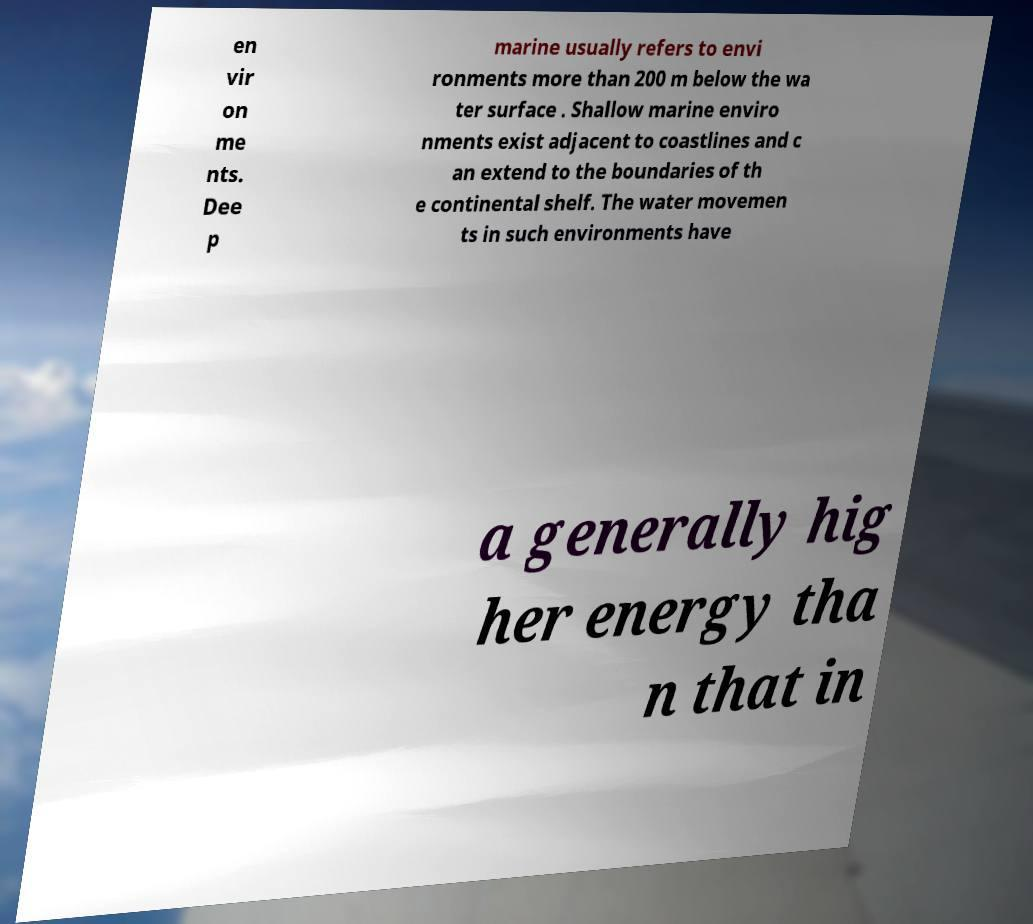Please identify and transcribe the text found in this image. en vir on me nts. Dee p marine usually refers to envi ronments more than 200 m below the wa ter surface . Shallow marine enviro nments exist adjacent to coastlines and c an extend to the boundaries of th e continental shelf. The water movemen ts in such environments have a generally hig her energy tha n that in 